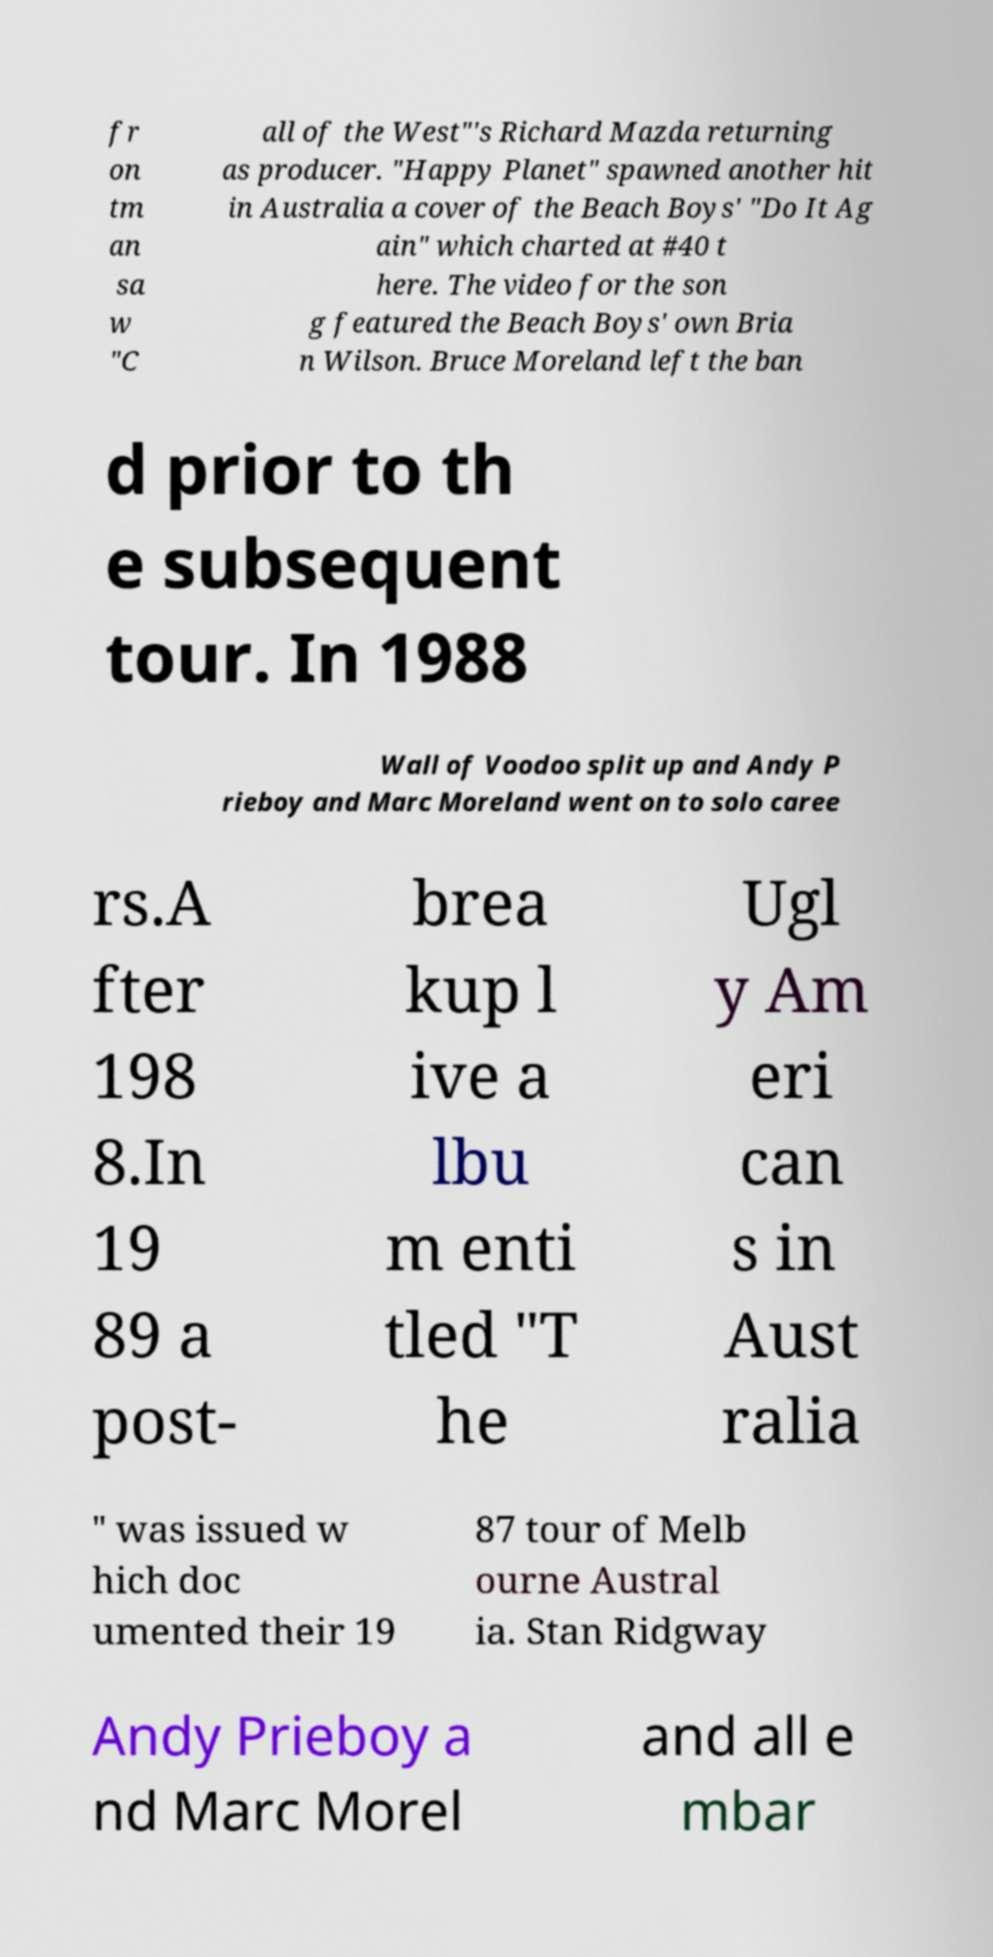Please read and relay the text visible in this image. What does it say? fr on tm an sa w "C all of the West"'s Richard Mazda returning as producer. "Happy Planet" spawned another hit in Australia a cover of the Beach Boys' "Do It Ag ain" which charted at #40 t here. The video for the son g featured the Beach Boys' own Bria n Wilson. Bruce Moreland left the ban d prior to th e subsequent tour. In 1988 Wall of Voodoo split up and Andy P rieboy and Marc Moreland went on to solo caree rs.A fter 198 8.In 19 89 a post- brea kup l ive a lbu m enti tled "T he Ugl y Am eri can s in Aust ralia " was issued w hich doc umented their 19 87 tour of Melb ourne Austral ia. Stan Ridgway Andy Prieboy a nd Marc Morel and all e mbar 